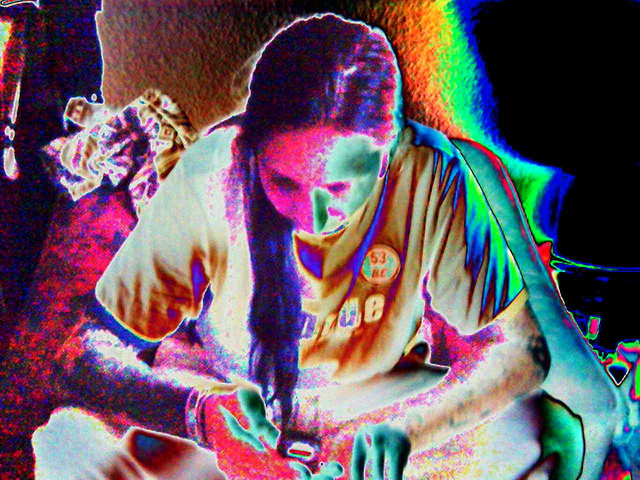Please identify all text content in this image. 53 